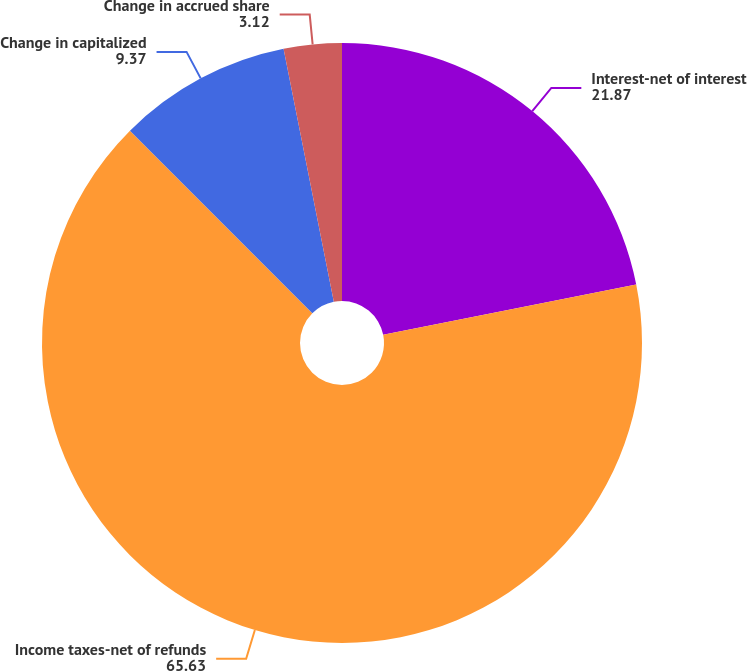Convert chart. <chart><loc_0><loc_0><loc_500><loc_500><pie_chart><fcel>Interest-net of interest<fcel>Income taxes-net of refunds<fcel>Change in capitalized<fcel>Change in accrued share<nl><fcel>21.87%<fcel>65.63%<fcel>9.37%<fcel>3.12%<nl></chart> 